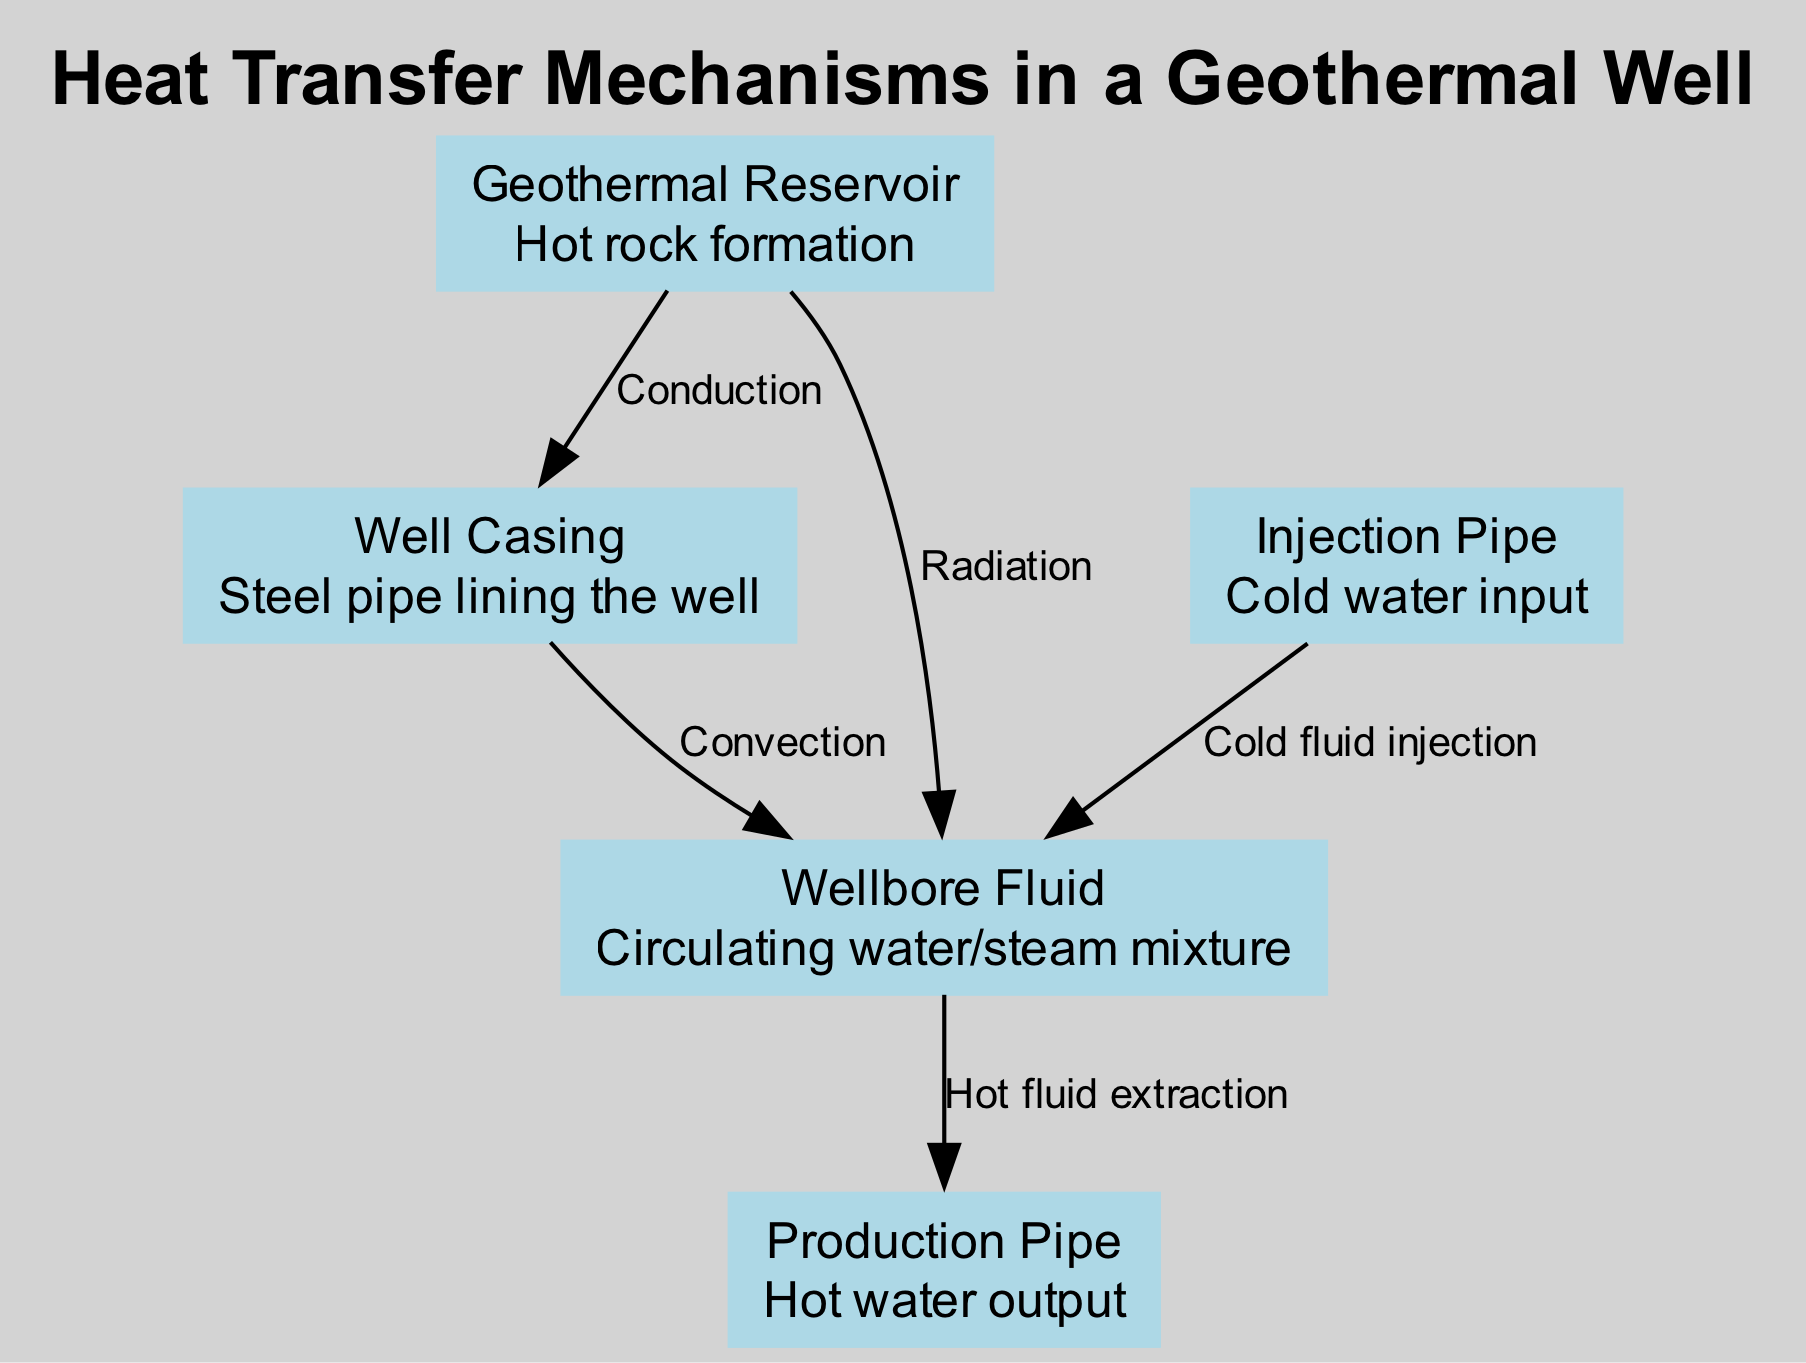What is the hot rock formation in the diagram? Referring to the diagram, the node labeled "Geothermal Reservoir" represents the hot rock formation.
Answer: Geothermal Reservoir How many nodes are present in the diagram? The diagram includes five nodes: Geothermal Reservoir, Well Casing, Injection Pipe, Production Pipe, and Wellbore Fluid.
Answer: 5 Which heat transfer mechanism occurs through rock and casing? The edge connecting the "Geothermal Reservoir" and "Well Casing" is labeled with "Conduction," indicating that heat transfer occurs through rock and casing.
Answer: Conduction What is the role of the "Injection Pipe" in the diagram? "Injection Pipe" is associated with cold water input to the well, as indicated by its description within the diagram.
Answer: Cold water input What type of heat transfer occurs between the "Well Casing" and "Wellbore Fluid"? The edge connecting the "Well Casing" to the "Wellbore Fluid" is labeled "Convection," indicating heat transfer via fluid circulation.
Answer: Convection Which node is associated with hot water output? The node "Production Pipe" in the diagram specifically describes the function of hot water output from the geothermal system.
Answer: Production Pipe Which heat transfer mechanism is described as minor in the diagram? The edge connecting the "Geothermal Reservoir" to the "Wellbore Fluid" is labeled "Radiation," marked as minor heat transfer through electromagnetic waves.
Answer: Radiation What does the "Wellbore Fluid" represent? The description for the "Wellbore Fluid" node indicates that it is a circulating water/steam mixture within the geothermal well system.
Answer: Circulating water/steam mixture What is transported from "Wellbore Fluid" to "Production Pipe"? The edge connecting "Wellbore Fluid" to "Production Pipe" denotes "Hot fluid extraction," indicating the flow direction of hot fluid.
Answer: Hot fluid extraction 